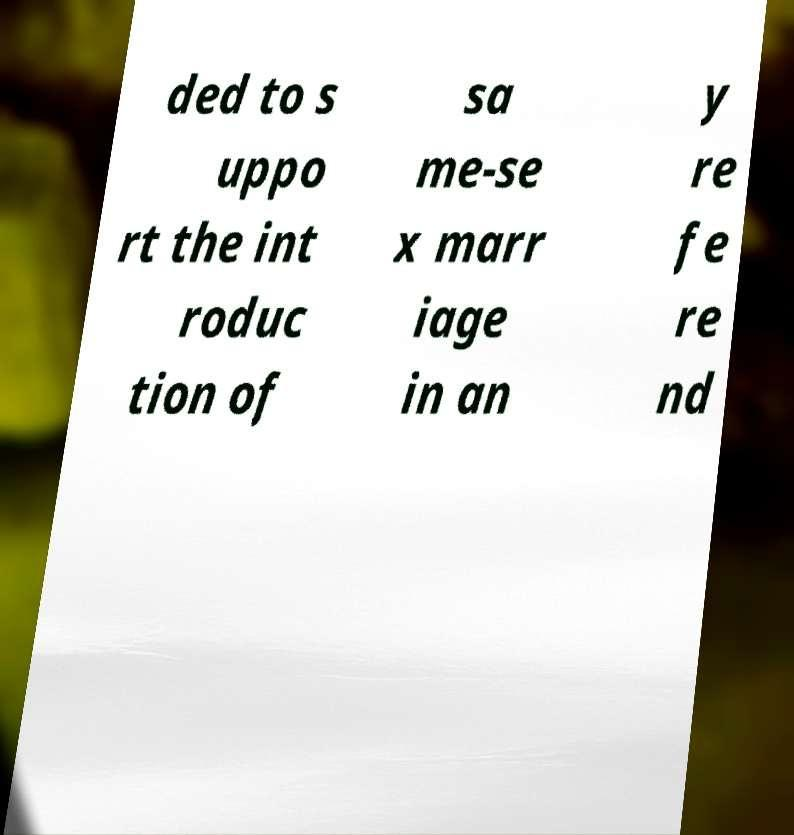For documentation purposes, I need the text within this image transcribed. Could you provide that? ded to s uppo rt the int roduc tion of sa me-se x marr iage in an y re fe re nd 